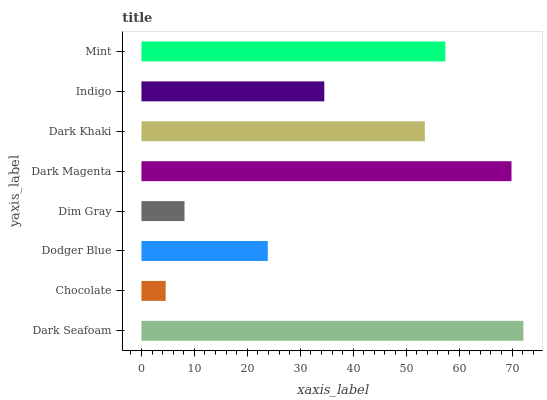Is Chocolate the minimum?
Answer yes or no. Yes. Is Dark Seafoam the maximum?
Answer yes or no. Yes. Is Dodger Blue the minimum?
Answer yes or no. No. Is Dodger Blue the maximum?
Answer yes or no. No. Is Dodger Blue greater than Chocolate?
Answer yes or no. Yes. Is Chocolate less than Dodger Blue?
Answer yes or no. Yes. Is Chocolate greater than Dodger Blue?
Answer yes or no. No. Is Dodger Blue less than Chocolate?
Answer yes or no. No. Is Dark Khaki the high median?
Answer yes or no. Yes. Is Indigo the low median?
Answer yes or no. Yes. Is Indigo the high median?
Answer yes or no. No. Is Dark Khaki the low median?
Answer yes or no. No. 